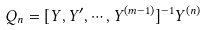<formula> <loc_0><loc_0><loc_500><loc_500>Q _ { n } = [ Y , Y ^ { \prime } , \cdots , Y ^ { ( m - 1 ) } ] ^ { - 1 } Y ^ { ( n ) }</formula> 